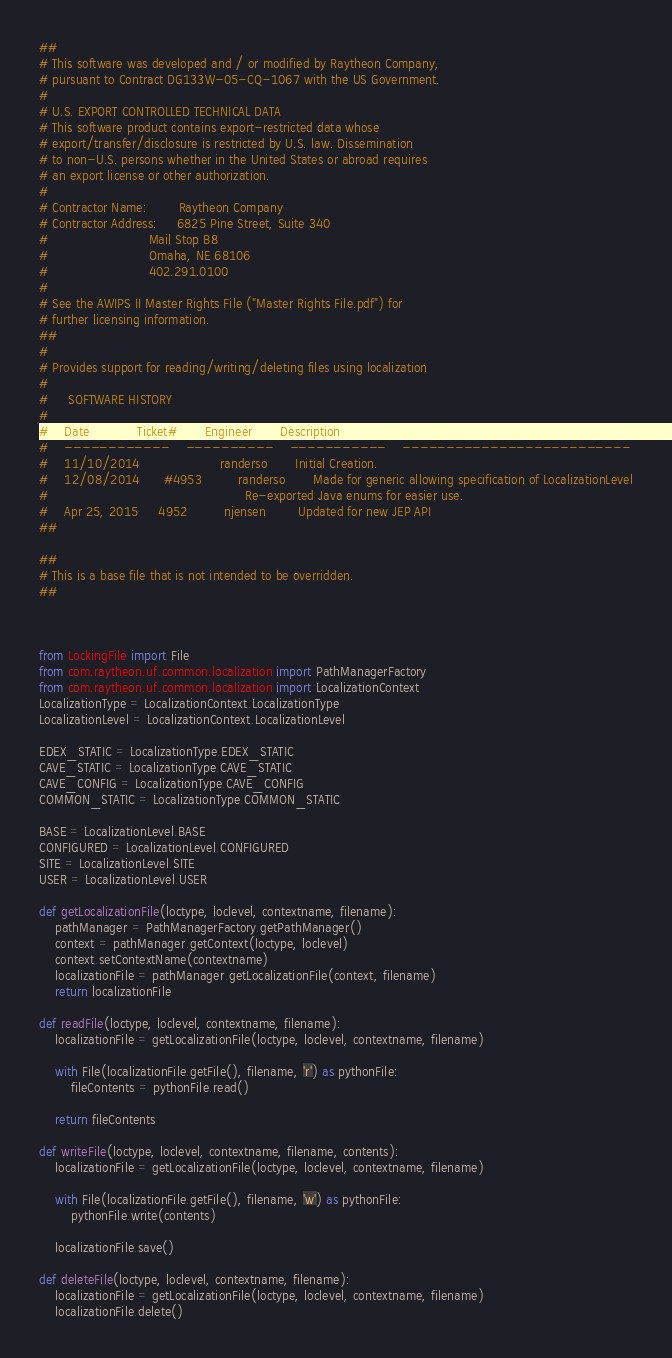Convert code to text. <code><loc_0><loc_0><loc_500><loc_500><_Python_>##
# This software was developed and / or modified by Raytheon Company,
# pursuant to Contract DG133W-05-CQ-1067 with the US Government.
# 
# U.S. EXPORT CONTROLLED TECHNICAL DATA
# This software product contains export-restricted data whose
# export/transfer/disclosure is restricted by U.S. law. Dissemination
# to non-U.S. persons whether in the United States or abroad requires
# an export license or other authorization.
# 
# Contractor Name:        Raytheon Company
# Contractor Address:     6825 Pine Street, Suite 340
#                         Mail Stop B8
#                         Omaha, NE 68106
#                         402.291.0100
# 
# See the AWIPS II Master Rights File ("Master Rights File.pdf") for
# further licensing information.
##
#
# Provides support for reading/writing/deleting files using localization
# 
#     SOFTWARE HISTORY
#    
#    Date            Ticket#       Engineer       Description
#    ------------    ----------    -----------    --------------------------
#    11/10/2014                    randerso       Initial Creation.
#    12/08/2014      #4953         randerso       Made for generic allowing specification of LocalizationLevel
#                                                 Re-exported Java enums for easier use.
#    Apr 25, 2015     4952         njensen        Updated for new JEP API
##

##
# This is a base file that is not intended to be overridden.
##



from LockingFile import File
from com.raytheon.uf.common.localization import PathManagerFactory
from com.raytheon.uf.common.localization import LocalizationContext
LocalizationType = LocalizationContext.LocalizationType
LocalizationLevel = LocalizationContext.LocalizationLevel

EDEX_STATIC = LocalizationType.EDEX_STATIC
CAVE_STATIC = LocalizationType.CAVE_STATIC
CAVE_CONFIG = LocalizationType.CAVE_CONFIG
COMMON_STATIC = LocalizationType.COMMON_STATIC

BASE = LocalizationLevel.BASE
CONFIGURED = LocalizationLevel.CONFIGURED
SITE = LocalizationLevel.SITE
USER = LocalizationLevel.USER

def getLocalizationFile(loctype, loclevel, contextname, filename):
    pathManager = PathManagerFactory.getPathManager()
    context = pathManager.getContext(loctype, loclevel)
    context.setContextName(contextname)
    localizationFile = pathManager.getLocalizationFile(context, filename)
    return localizationFile

def readFile(loctype, loclevel, contextname, filename):
    localizationFile = getLocalizationFile(loctype, loclevel, contextname, filename)

    with File(localizationFile.getFile(), filename, 'r') as pythonFile:
        fileContents = pythonFile.read()
    
    return fileContents
    
def writeFile(loctype, loclevel, contextname, filename, contents):
    localizationFile = getLocalizationFile(loctype, loclevel, contextname, filename)
    
    with File(localizationFile.getFile(), filename, 'w') as pythonFile:
        pythonFile.write(contents)
    
    localizationFile.save()

def deleteFile(loctype, loclevel, contextname, filename):
    localizationFile = getLocalizationFile(loctype, loclevel, contextname, filename)
    localizationFile.delete()
</code> 